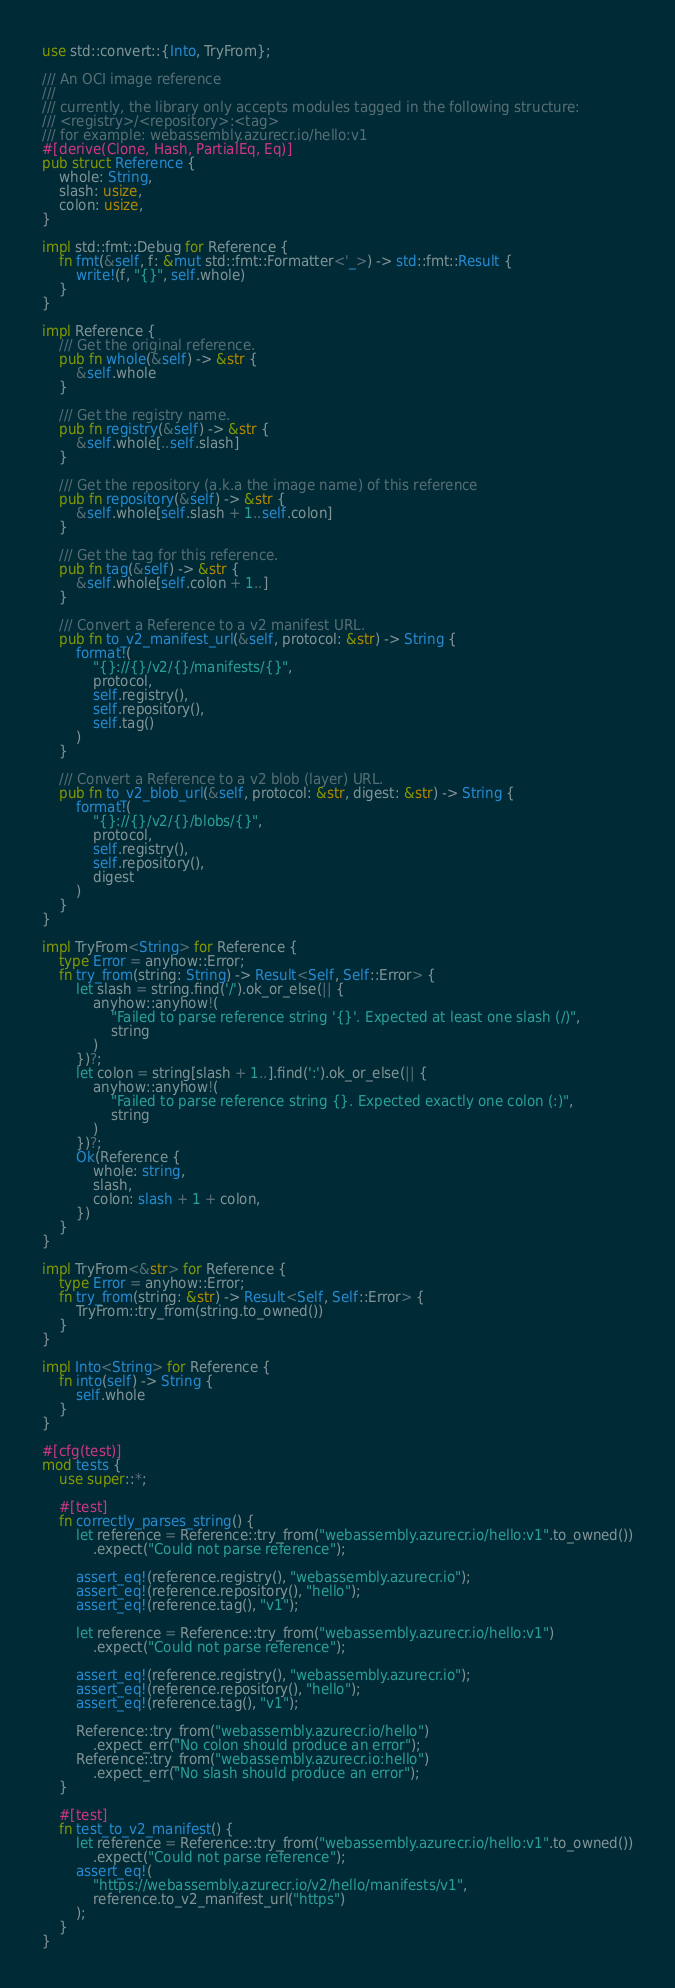<code> <loc_0><loc_0><loc_500><loc_500><_Rust_>use std::convert::{Into, TryFrom};

/// An OCI image reference
///
/// currently, the library only accepts modules tagged in the following structure:
/// <registry>/<repository>:<tag>
/// for example: webassembly.azurecr.io/hello:v1
#[derive(Clone, Hash, PartialEq, Eq)]
pub struct Reference {
    whole: String,
    slash: usize,
    colon: usize,
}

impl std::fmt::Debug for Reference {
    fn fmt(&self, f: &mut std::fmt::Formatter<'_>) -> std::fmt::Result {
        write!(f, "{}", self.whole)
    }
}

impl Reference {
    /// Get the original reference.
    pub fn whole(&self) -> &str {
        &self.whole
    }

    /// Get the registry name.
    pub fn registry(&self) -> &str {
        &self.whole[..self.slash]
    }

    /// Get the repository (a.k.a the image name) of this reference
    pub fn repository(&self) -> &str {
        &self.whole[self.slash + 1..self.colon]
    }

    /// Get the tag for this reference.
    pub fn tag(&self) -> &str {
        &self.whole[self.colon + 1..]
    }

    /// Convert a Reference to a v2 manifest URL.
    pub fn to_v2_manifest_url(&self, protocol: &str) -> String {
        format!(
            "{}://{}/v2/{}/manifests/{}",
            protocol,
            self.registry(),
            self.repository(),
            self.tag()
        )
    }

    /// Convert a Reference to a v2 blob (layer) URL.
    pub fn to_v2_blob_url(&self, protocol: &str, digest: &str) -> String {
        format!(
            "{}://{}/v2/{}/blobs/{}",
            protocol,
            self.registry(),
            self.repository(),
            digest
        )
    }
}

impl TryFrom<String> for Reference {
    type Error = anyhow::Error;
    fn try_from(string: String) -> Result<Self, Self::Error> {
        let slash = string.find('/').ok_or_else(|| {
            anyhow::anyhow!(
                "Failed to parse reference string '{}'. Expected at least one slash (/)",
                string
            )
        })?;
        let colon = string[slash + 1..].find(':').ok_or_else(|| {
            anyhow::anyhow!(
                "Failed to parse reference string {}. Expected exactly one colon (:)",
                string
            )
        })?;
        Ok(Reference {
            whole: string,
            slash,
            colon: slash + 1 + colon,
        })
    }
}

impl TryFrom<&str> for Reference {
    type Error = anyhow::Error;
    fn try_from(string: &str) -> Result<Self, Self::Error> {
        TryFrom::try_from(string.to_owned())
    }
}

impl Into<String> for Reference {
    fn into(self) -> String {
        self.whole
    }
}

#[cfg(test)]
mod tests {
    use super::*;

    #[test]
    fn correctly_parses_string() {
        let reference = Reference::try_from("webassembly.azurecr.io/hello:v1".to_owned())
            .expect("Could not parse reference");

        assert_eq!(reference.registry(), "webassembly.azurecr.io");
        assert_eq!(reference.repository(), "hello");
        assert_eq!(reference.tag(), "v1");

        let reference = Reference::try_from("webassembly.azurecr.io/hello:v1")
            .expect("Could not parse reference");

        assert_eq!(reference.registry(), "webassembly.azurecr.io");
        assert_eq!(reference.repository(), "hello");
        assert_eq!(reference.tag(), "v1");

        Reference::try_from("webassembly.azurecr.io/hello")
            .expect_err("No colon should produce an error");
        Reference::try_from("webassembly.azurecr.io:hello")
            .expect_err("No slash should produce an error");
    }

    #[test]
    fn test_to_v2_manifest() {
        let reference = Reference::try_from("webassembly.azurecr.io/hello:v1".to_owned())
            .expect("Could not parse reference");
        assert_eq!(
            "https://webassembly.azurecr.io/v2/hello/manifests/v1",
            reference.to_v2_manifest_url("https")
        );
    }
}
</code> 